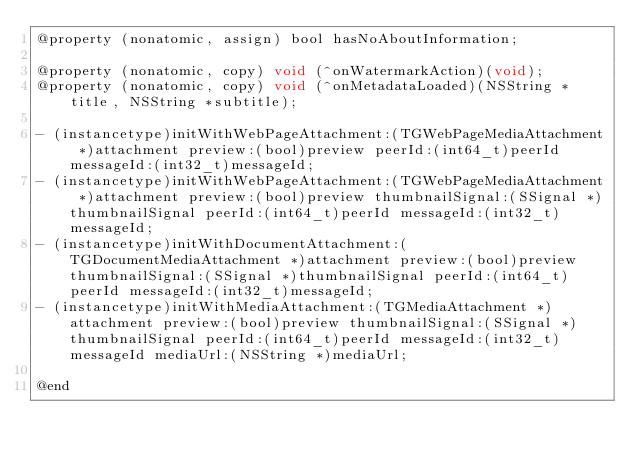Convert code to text. <code><loc_0><loc_0><loc_500><loc_500><_C_>@property (nonatomic, assign) bool hasNoAboutInformation;

@property (nonatomic, copy) void (^onWatermarkAction)(void);
@property (nonatomic, copy) void (^onMetadataLoaded)(NSString *title, NSString *subtitle);

- (instancetype)initWithWebPageAttachment:(TGWebPageMediaAttachment *)attachment preview:(bool)preview peerId:(int64_t)peerId messageId:(int32_t)messageId;
- (instancetype)initWithWebPageAttachment:(TGWebPageMediaAttachment *)attachment preview:(bool)preview thumbnailSignal:(SSignal *)thumbnailSignal peerId:(int64_t)peerId messageId:(int32_t)messageId;
- (instancetype)initWithDocumentAttachment:(TGDocumentMediaAttachment *)attachment preview:(bool)preview thumbnailSignal:(SSignal *)thumbnailSignal peerId:(int64_t)peerId messageId:(int32_t)messageId;
- (instancetype)initWithMediaAttachment:(TGMediaAttachment *)attachment preview:(bool)preview thumbnailSignal:(SSignal *)thumbnailSignal peerId:(int64_t)peerId messageId:(int32_t)messageId mediaUrl:(NSString *)mediaUrl;

@end
</code> 